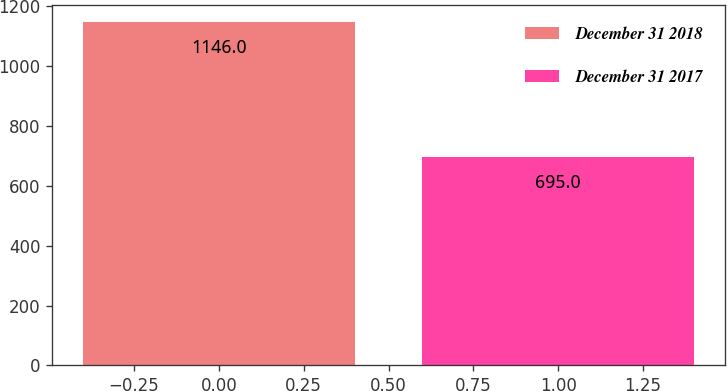Convert chart. <chart><loc_0><loc_0><loc_500><loc_500><bar_chart><fcel>December 31 2018<fcel>December 31 2017<nl><fcel>1146<fcel>695<nl></chart> 